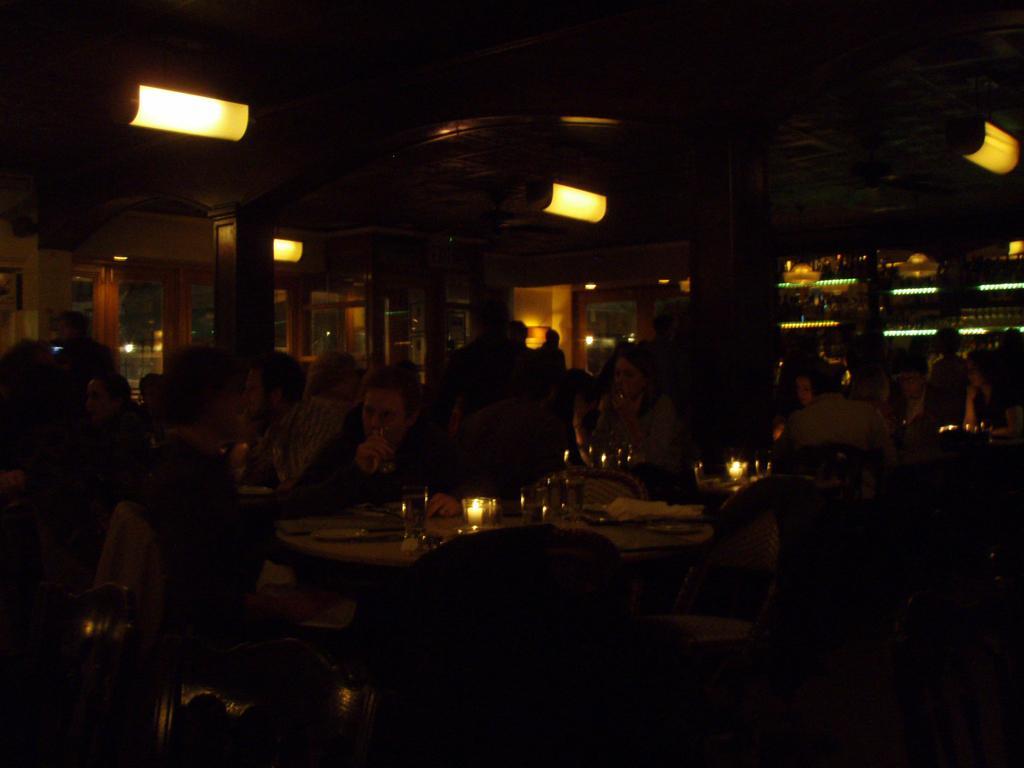Describe this image in one or two sentences. In this image there are group of persons, there are tables, there are chairs, there are objects on the table, there is a chair truncated towards the bottom of the image, there is are windows, there are pillars, there are lights, there is the roof. 